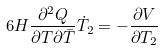<formula> <loc_0><loc_0><loc_500><loc_500>6 H \frac { \partial ^ { 2 } Q } { \partial T \partial { \bar { T } } } \dot { T } _ { 2 } = - \frac { \partial V } { \partial T _ { 2 } }</formula> 